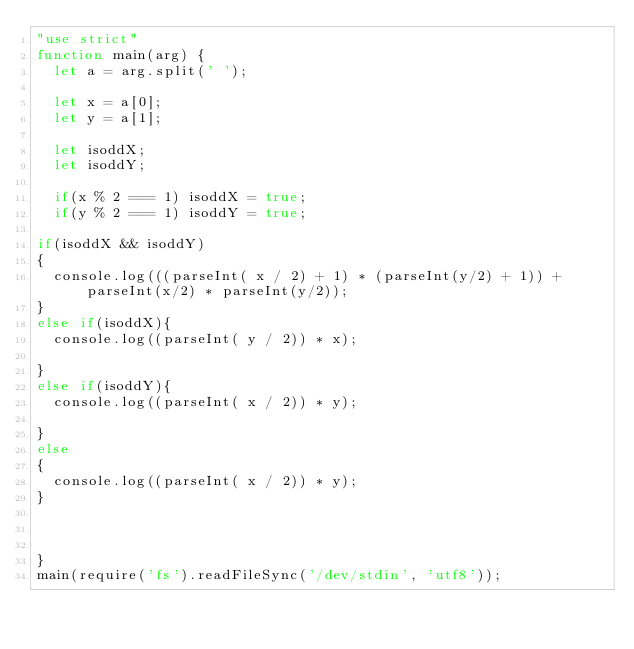<code> <loc_0><loc_0><loc_500><loc_500><_JavaScript_>"use strict"
function main(arg) {
	let a = arg.split(' ');

	let x = a[0];
	let y = a[1];

	let isoddX;
	let isoddY;

	if(x % 2 === 1) isoddX = true;
	if(y % 2 === 1) isoddY = true;
	
if(isoddX && isoddY)
{
	console.log(((parseInt( x / 2) + 1) * (parseInt(y/2) + 1)) +  parseInt(x/2) * parseInt(y/2));
}
else if(isoddX){
	console.log((parseInt( y / 2)) * x);

}
else if(isoddY){
	console.log((parseInt( x / 2)) * y);

}
else
{
	console.log((parseInt( x / 2)) * y);
}



}
main(require('fs').readFileSync('/dev/stdin', 'utf8'));</code> 